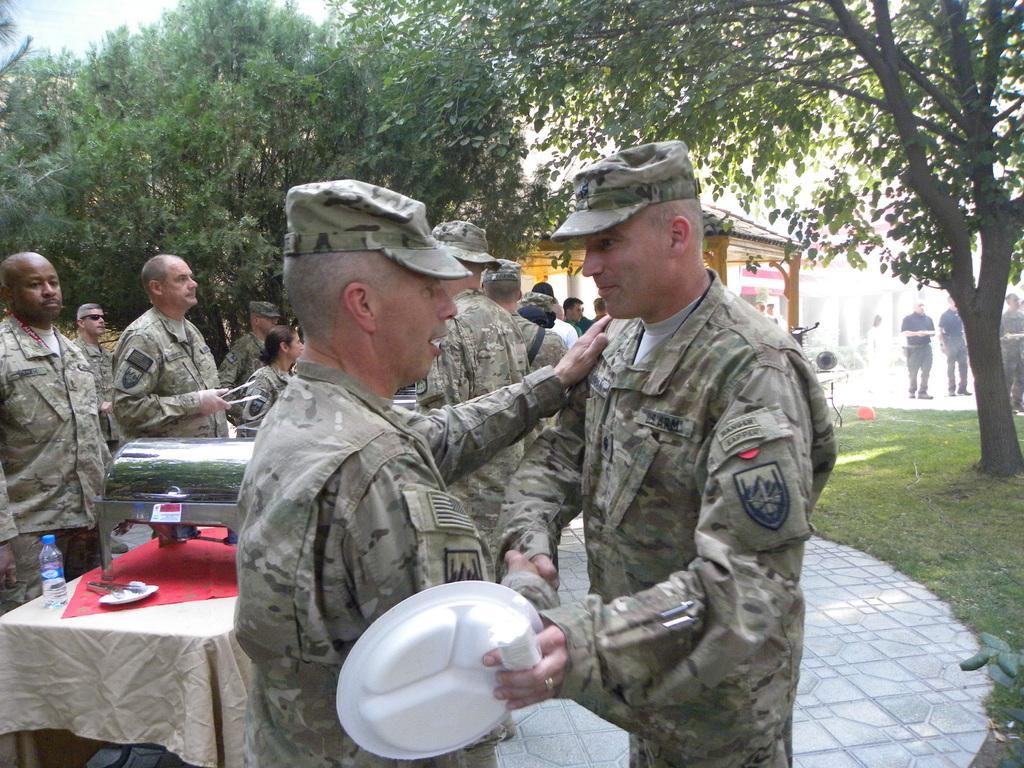In one or two sentences, can you explain what this image depicts? In this image in the foreground we can see there are two people shaking hands with each others. 